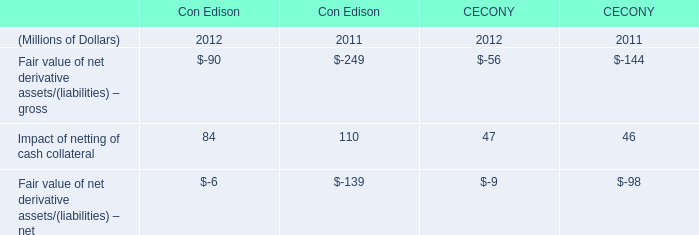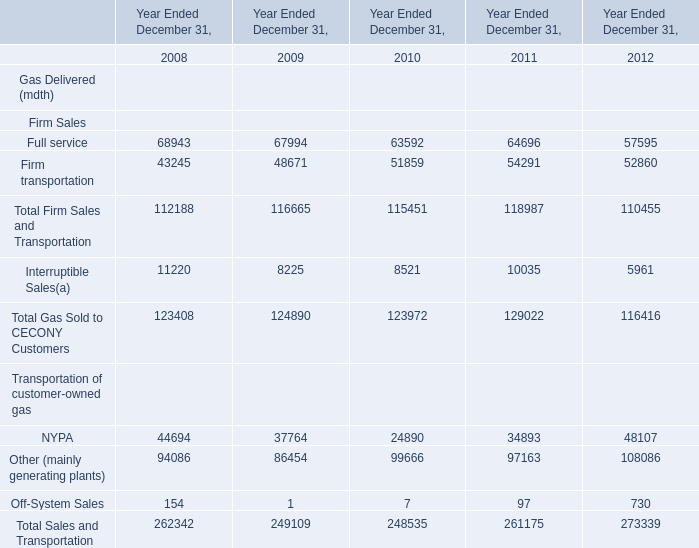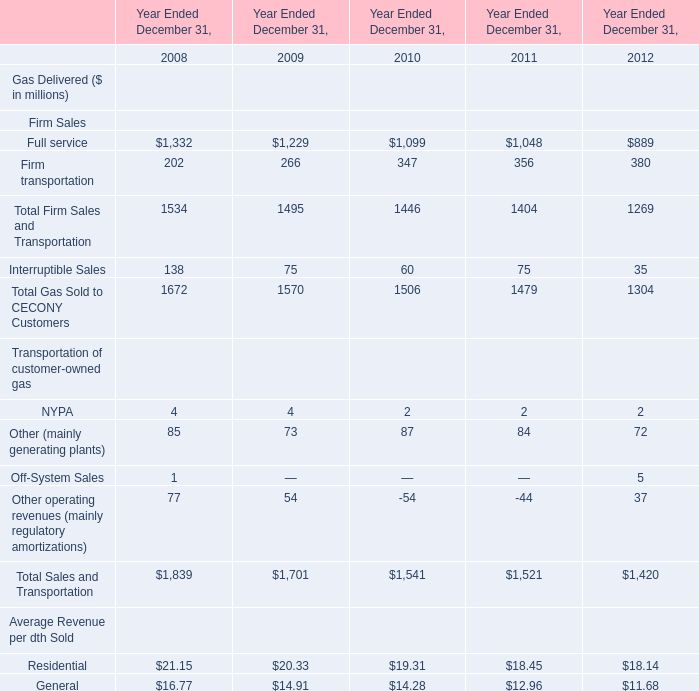In what year the Total Gas Sold to CECONY Customers is positive? 
Answer: 2008. 